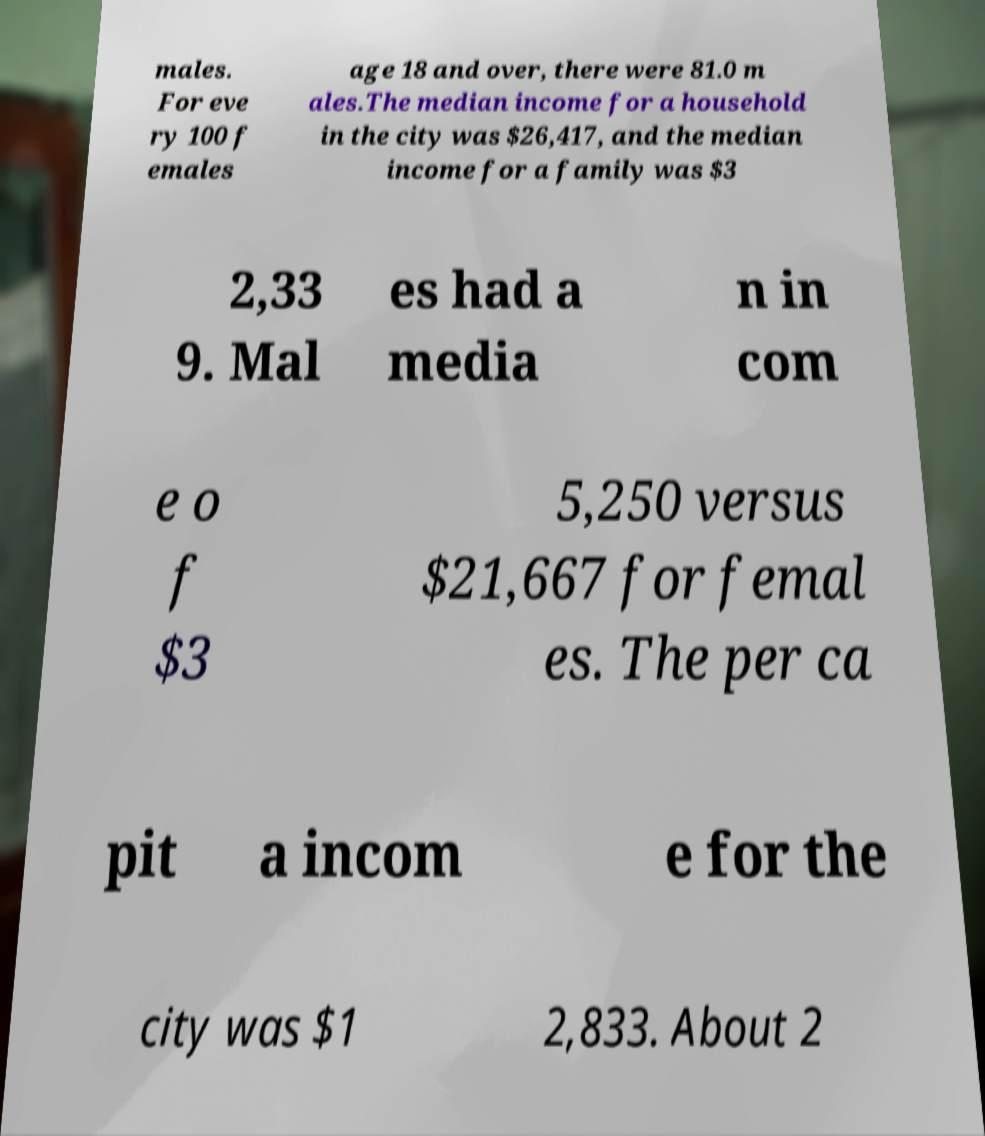Please read and relay the text visible in this image. What does it say? males. For eve ry 100 f emales age 18 and over, there were 81.0 m ales.The median income for a household in the city was $26,417, and the median income for a family was $3 2,33 9. Mal es had a media n in com e o f $3 5,250 versus $21,667 for femal es. The per ca pit a incom e for the city was $1 2,833. About 2 